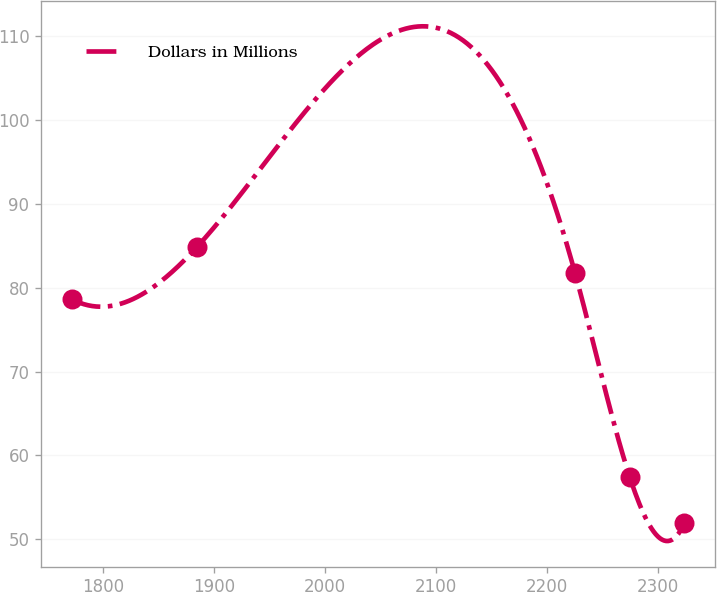Convert chart to OTSL. <chart><loc_0><loc_0><loc_500><loc_500><line_chart><ecel><fcel>Dollars in Millions<nl><fcel>1771.77<fcel>78.63<nl><fcel>1884.93<fcel>84.91<nl><fcel>2225.09<fcel>81.77<nl><fcel>2274.4<fcel>57.42<nl><fcel>2323.71<fcel>51.91<nl></chart> 